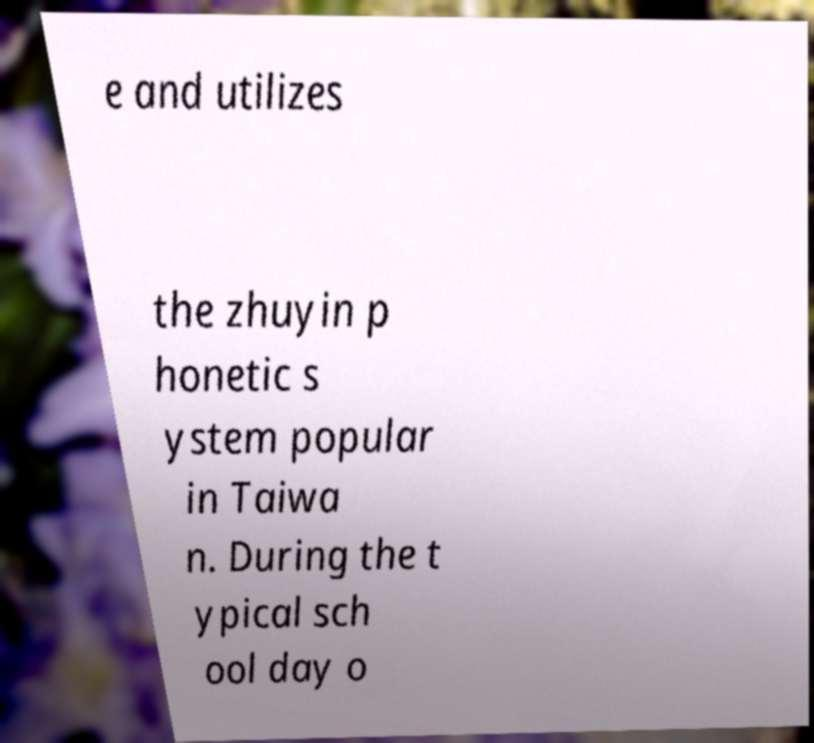There's text embedded in this image that I need extracted. Can you transcribe it verbatim? e and utilizes the zhuyin p honetic s ystem popular in Taiwa n. During the t ypical sch ool day o 